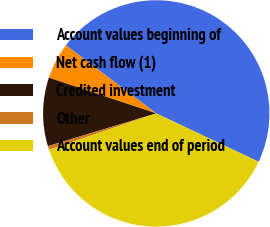Convert chart. <chart><loc_0><loc_0><loc_500><loc_500><pie_chart><fcel>Account values beginning of<fcel>Net cash flow (1)<fcel>Credited investment<fcel>Other<fcel>Account values end of period<nl><fcel>46.74%<fcel>5.16%<fcel>9.78%<fcel>0.54%<fcel>37.77%<nl></chart> 